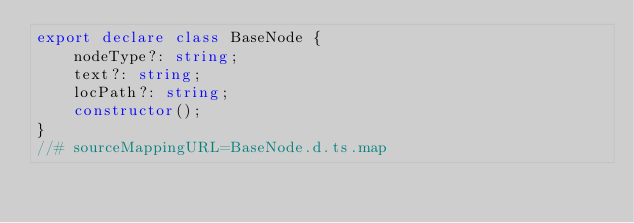Convert code to text. <code><loc_0><loc_0><loc_500><loc_500><_TypeScript_>export declare class BaseNode {
    nodeType?: string;
    text?: string;
    locPath?: string;
    constructor();
}
//# sourceMappingURL=BaseNode.d.ts.map</code> 